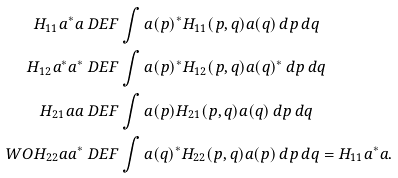<formula> <loc_0><loc_0><loc_500><loc_500>H _ { 1 1 } a ^ { * } a & \ D E F \int a ( p ) ^ { * } H _ { 1 1 } ( p , q ) a ( q ) \, d p \, d q \\ H _ { 1 2 } a ^ { * } a ^ { * } & \ D E F \int a ( p ) ^ { * } H _ { 1 2 } ( p , q ) a ( q ) ^ { * } \, d p \, d q \\ H _ { 2 1 } a a & \ D E F \int a ( p ) H _ { 2 1 } ( p , q ) a ( q ) \, d p \, d q \\ \ W O { H _ { 2 2 } a a ^ { * } } & \ D E F \int a ( q ) ^ { * } H _ { 2 2 } ( p , q ) a ( p ) \, d p \, d q = H _ { 1 1 } a ^ { * } a .</formula> 